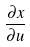<formula> <loc_0><loc_0><loc_500><loc_500>\frac { \partial x } { \partial u }</formula> 